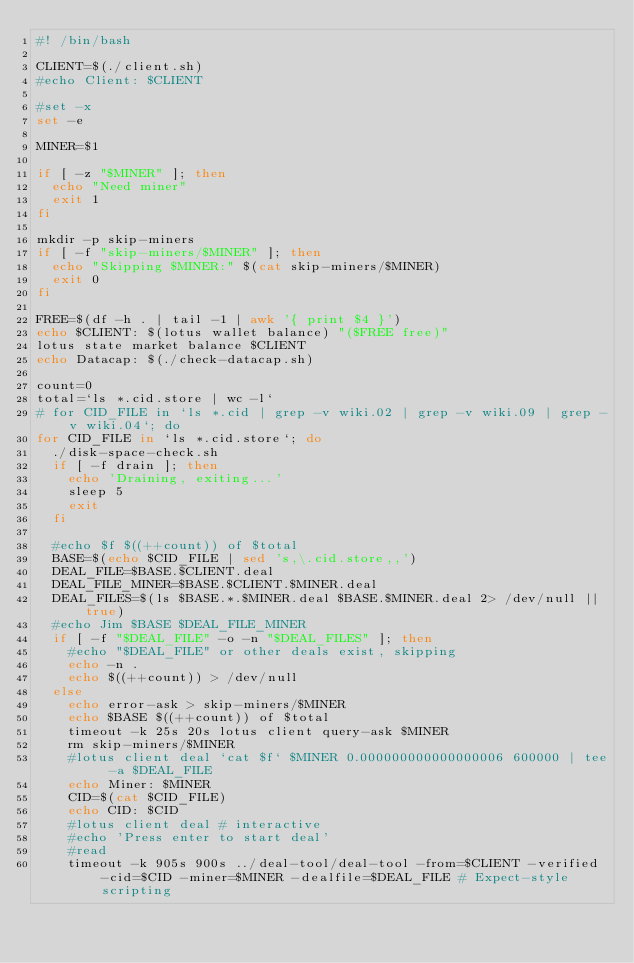Convert code to text. <code><loc_0><loc_0><loc_500><loc_500><_Bash_>#! /bin/bash

CLIENT=$(./client.sh)
#echo Client: $CLIENT

#set -x
set -e

MINER=$1

if [ -z "$MINER" ]; then
	echo "Need miner"
	exit 1
fi

mkdir -p skip-miners
if [ -f "skip-miners/$MINER" ]; then
  echo "Skipping $MINER:" $(cat skip-miners/$MINER)
  exit 0
fi

FREE=$(df -h . | tail -1 | awk '{ print $4 }')
echo $CLIENT: $(lotus wallet balance) "($FREE free)"
lotus state market balance $CLIENT
echo Datacap: $(./check-datacap.sh)

count=0
total=`ls *.cid.store | wc -l`
# for CID_FILE in `ls *.cid | grep -v wiki.02 | grep -v wiki.09 | grep -v wiki.04`; do
for CID_FILE in `ls *.cid.store`; do
  ./disk-space-check.sh
  if [ -f drain ]; then
    echo 'Draining, exiting...'
    sleep 5
    exit
  fi

	#echo $f $((++count)) of $total
	BASE=$(echo $CID_FILE | sed 's,\.cid.store,,')
	DEAL_FILE=$BASE.$CLIENT.deal
	DEAL_FILE_MINER=$BASE.$CLIENT.$MINER.deal
	DEAL_FILES=$(ls $BASE.*.$MINER.deal $BASE.$MINER.deal 2> /dev/null || true)
	#echo Jim $BASE $DEAL_FILE_MINER
	if [ -f "$DEAL_FILE" -o -n "$DEAL_FILES" ]; then
		#echo "$DEAL_FILE" or other deals exist, skipping
		echo -n .
		echo $((++count)) > /dev/null
	else
		echo error-ask > skip-miners/$MINER
		echo $BASE $((++count)) of $total
		timeout -k 25s 20s lotus client query-ask $MINER
    rm skip-miners/$MINER
		#lotus client deal `cat $f` $MINER 0.000000000000000006 600000 | tee -a $DEAL_FILE
		echo Miner: $MINER
    CID=$(cat $CID_FILE)
		echo CID: $CID
		#lotus client deal # interactive
    #echo 'Press enter to start deal'
    #read
    timeout -k 905s 900s ../deal-tool/deal-tool -from=$CLIENT -verified -cid=$CID -miner=$MINER -dealfile=$DEAL_FILE # Expect-style scripting</code> 